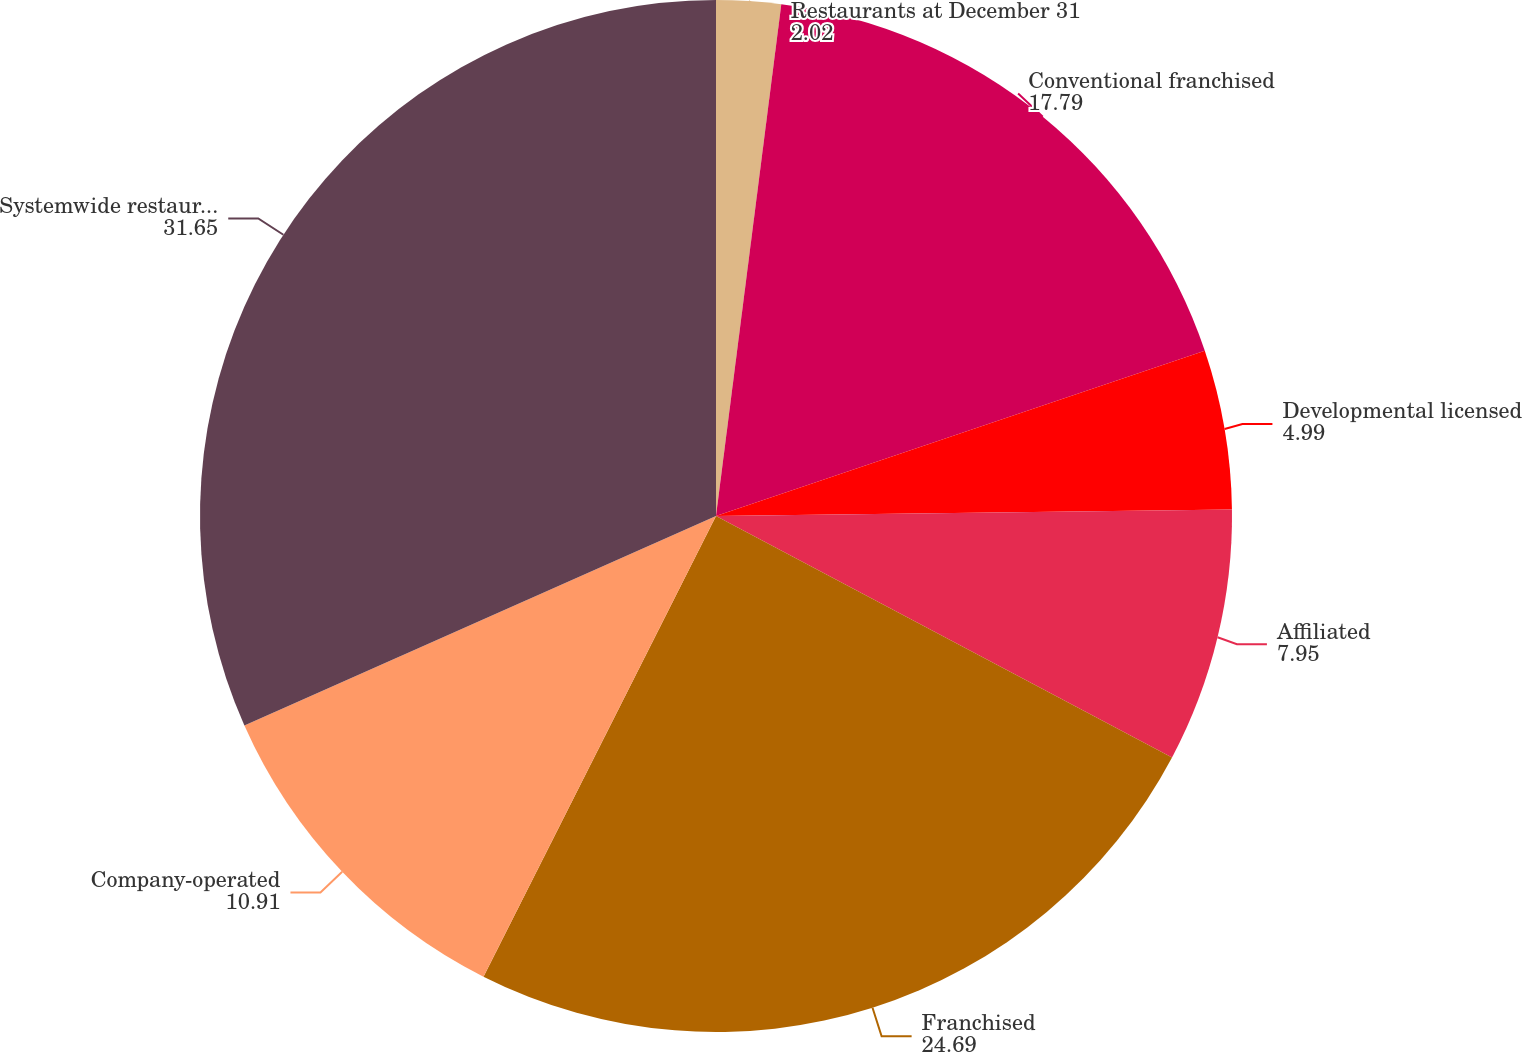Convert chart to OTSL. <chart><loc_0><loc_0><loc_500><loc_500><pie_chart><fcel>Restaurants at December 31<fcel>Conventional franchised<fcel>Developmental licensed<fcel>Affiliated<fcel>Franchised<fcel>Company-operated<fcel>Systemwide restaurants<nl><fcel>2.02%<fcel>17.79%<fcel>4.99%<fcel>7.95%<fcel>24.69%<fcel>10.91%<fcel>31.65%<nl></chart> 